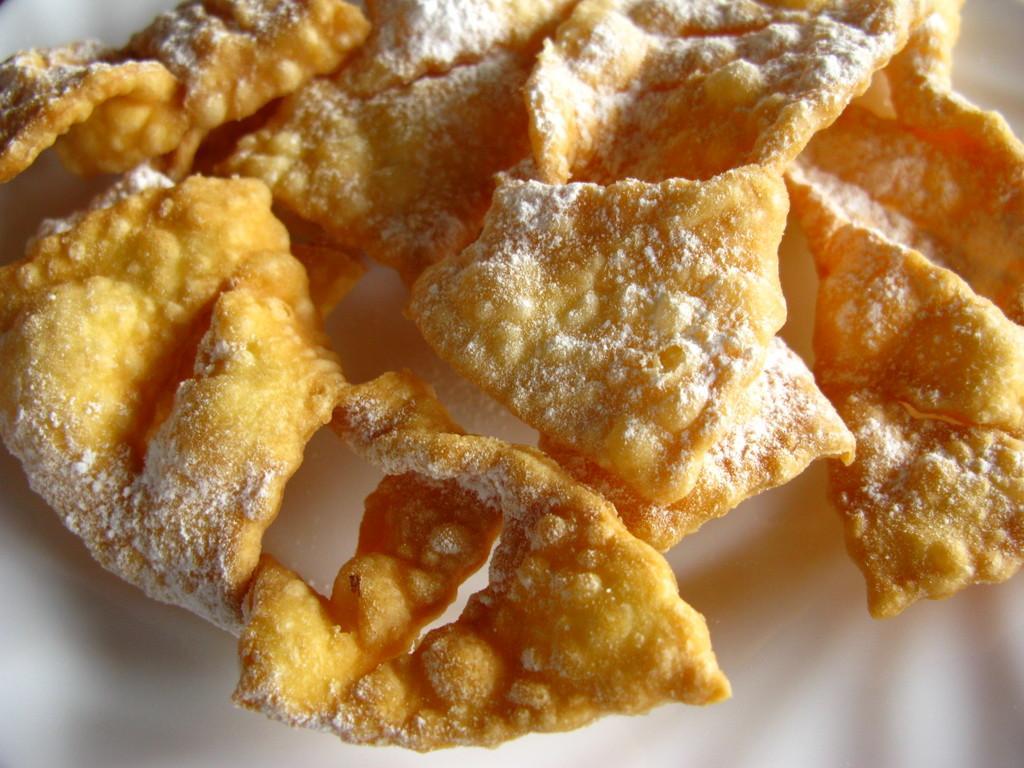Could you give a brief overview of what you see in this image? In this image we can see there is a food item placed on a plate. 